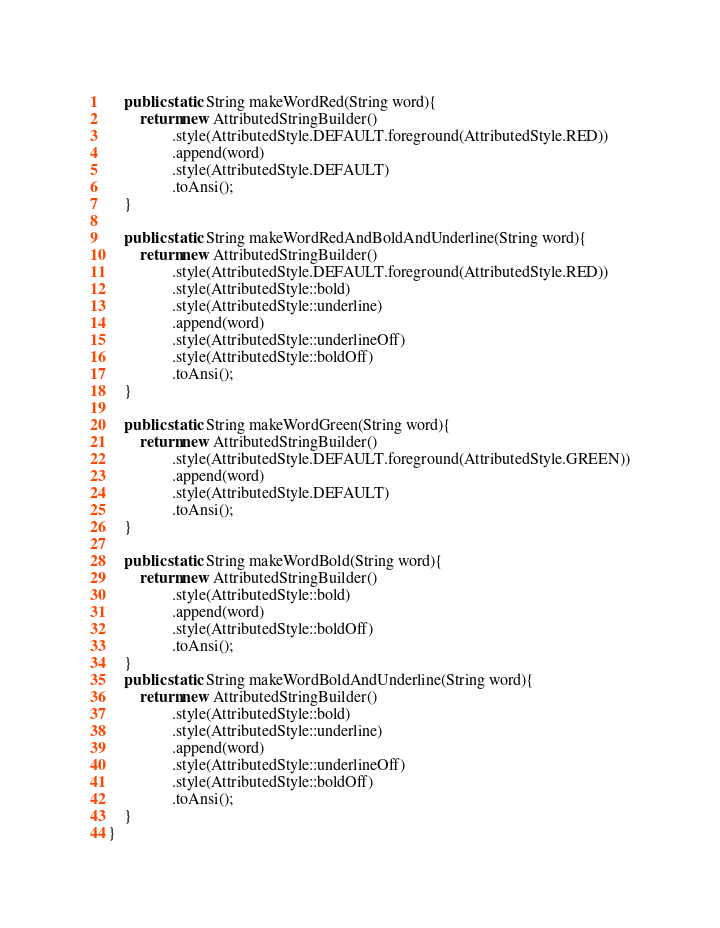Convert code to text. <code><loc_0><loc_0><loc_500><loc_500><_Java_>
    public static String makeWordRed(String word){
        return new AttributedStringBuilder()
                .style(AttributedStyle.DEFAULT.foreground(AttributedStyle.RED))
                .append(word)
                .style(AttributedStyle.DEFAULT)
                .toAnsi();
    }

    public static String makeWordRedAndBoldAndUnderline(String word){
        return new AttributedStringBuilder()
                .style(AttributedStyle.DEFAULT.foreground(AttributedStyle.RED))
                .style(AttributedStyle::bold)
                .style(AttributedStyle::underline)
                .append(word)
                .style(AttributedStyle::underlineOff)
                .style(AttributedStyle::boldOff)
                .toAnsi();
    }

    public static String makeWordGreen(String word){
        return new AttributedStringBuilder()
                .style(AttributedStyle.DEFAULT.foreground(AttributedStyle.GREEN))
                .append(word)
                .style(AttributedStyle.DEFAULT)
                .toAnsi();
    }

    public static String makeWordBold(String word){
        return new AttributedStringBuilder()
                .style(AttributedStyle::bold)
                .append(word)
                .style(AttributedStyle::boldOff)
                .toAnsi();
    }
    public static String makeWordBoldAndUnderline(String word){
        return new AttributedStringBuilder()
                .style(AttributedStyle::bold)
                .style(AttributedStyle::underline)
                .append(word)
                .style(AttributedStyle::underlineOff)
                .style(AttributedStyle::boldOff)
                .toAnsi();
    }
}
</code> 